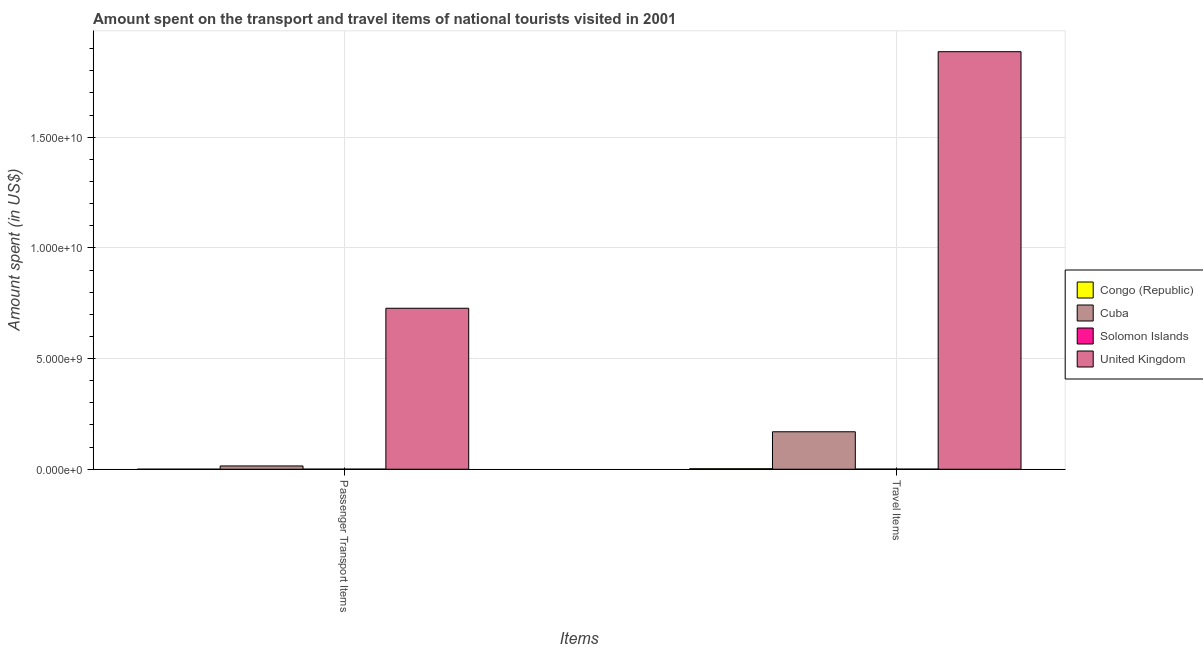How many different coloured bars are there?
Your answer should be very brief. 4. Are the number of bars per tick equal to the number of legend labels?
Make the answer very short. Yes. Are the number of bars on each tick of the X-axis equal?
Offer a very short reply. Yes. How many bars are there on the 2nd tick from the left?
Make the answer very short. 4. What is the label of the 2nd group of bars from the left?
Ensure brevity in your answer.  Travel Items. What is the amount spent on passenger transport items in Cuba?
Offer a terse response. 1.48e+08. Across all countries, what is the maximum amount spent in travel items?
Ensure brevity in your answer.  1.89e+1. Across all countries, what is the minimum amount spent on passenger transport items?
Your response must be concise. 6.00e+05. In which country was the amount spent on passenger transport items minimum?
Provide a short and direct response. Congo (Republic). What is the total amount spent in travel items in the graph?
Your answer should be compact. 2.06e+1. What is the difference between the amount spent in travel items in Cuba and that in Congo (Republic)?
Provide a short and direct response. 1.67e+09. What is the difference between the amount spent in travel items in Congo (Republic) and the amount spent on passenger transport items in Solomon Islands?
Make the answer very short. 1.84e+07. What is the average amount spent in travel items per country?
Your response must be concise. 5.15e+09. What is the difference between the amount spent in travel items and amount spent on passenger transport items in Congo (Republic)?
Keep it short and to the point. 2.14e+07. In how many countries, is the amount spent on passenger transport items greater than 13000000000 US$?
Offer a very short reply. 0. What is the ratio of the amount spent in travel items in Congo (Republic) to that in Solomon Islands?
Provide a short and direct response. 4.23. Is the amount spent in travel items in Solomon Islands less than that in Cuba?
Ensure brevity in your answer.  Yes. In how many countries, is the amount spent on passenger transport items greater than the average amount spent on passenger transport items taken over all countries?
Give a very brief answer. 1. What does the 3rd bar from the left in Passenger Transport Items represents?
Offer a terse response. Solomon Islands. What does the 4th bar from the right in Travel Items represents?
Offer a terse response. Congo (Republic). How many bars are there?
Offer a terse response. 8. How many countries are there in the graph?
Provide a short and direct response. 4. What is the difference between two consecutive major ticks on the Y-axis?
Offer a terse response. 5.00e+09. Are the values on the major ticks of Y-axis written in scientific E-notation?
Offer a very short reply. Yes. Where does the legend appear in the graph?
Offer a terse response. Center right. How many legend labels are there?
Offer a terse response. 4. How are the legend labels stacked?
Offer a very short reply. Vertical. What is the title of the graph?
Provide a succinct answer. Amount spent on the transport and travel items of national tourists visited in 2001. What is the label or title of the X-axis?
Keep it short and to the point. Items. What is the label or title of the Y-axis?
Provide a short and direct response. Amount spent (in US$). What is the Amount spent (in US$) of Congo (Republic) in Passenger Transport Items?
Provide a succinct answer. 6.00e+05. What is the Amount spent (in US$) in Cuba in Passenger Transport Items?
Provide a short and direct response. 1.48e+08. What is the Amount spent (in US$) of Solomon Islands in Passenger Transport Items?
Offer a very short reply. 3.60e+06. What is the Amount spent (in US$) of United Kingdom in Passenger Transport Items?
Offer a very short reply. 7.27e+09. What is the Amount spent (in US$) of Congo (Republic) in Travel Items?
Provide a succinct answer. 2.20e+07. What is the Amount spent (in US$) in Cuba in Travel Items?
Provide a succinct answer. 1.69e+09. What is the Amount spent (in US$) of Solomon Islands in Travel Items?
Give a very brief answer. 5.20e+06. What is the Amount spent (in US$) in United Kingdom in Travel Items?
Your response must be concise. 1.89e+1. Across all Items, what is the maximum Amount spent (in US$) in Congo (Republic)?
Ensure brevity in your answer.  2.20e+07. Across all Items, what is the maximum Amount spent (in US$) in Cuba?
Offer a terse response. 1.69e+09. Across all Items, what is the maximum Amount spent (in US$) of Solomon Islands?
Ensure brevity in your answer.  5.20e+06. Across all Items, what is the maximum Amount spent (in US$) of United Kingdom?
Offer a very short reply. 1.89e+1. Across all Items, what is the minimum Amount spent (in US$) of Cuba?
Keep it short and to the point. 1.48e+08. Across all Items, what is the minimum Amount spent (in US$) in Solomon Islands?
Your response must be concise. 3.60e+06. Across all Items, what is the minimum Amount spent (in US$) of United Kingdom?
Your answer should be compact. 7.27e+09. What is the total Amount spent (in US$) of Congo (Republic) in the graph?
Your answer should be compact. 2.26e+07. What is the total Amount spent (in US$) in Cuba in the graph?
Keep it short and to the point. 1.84e+09. What is the total Amount spent (in US$) in Solomon Islands in the graph?
Provide a short and direct response. 8.80e+06. What is the total Amount spent (in US$) in United Kingdom in the graph?
Make the answer very short. 2.61e+1. What is the difference between the Amount spent (in US$) in Congo (Republic) in Passenger Transport Items and that in Travel Items?
Offer a terse response. -2.14e+07. What is the difference between the Amount spent (in US$) of Cuba in Passenger Transport Items and that in Travel Items?
Your response must be concise. -1.54e+09. What is the difference between the Amount spent (in US$) of Solomon Islands in Passenger Transport Items and that in Travel Items?
Provide a succinct answer. -1.60e+06. What is the difference between the Amount spent (in US$) of United Kingdom in Passenger Transport Items and that in Travel Items?
Your answer should be compact. -1.16e+1. What is the difference between the Amount spent (in US$) of Congo (Republic) in Passenger Transport Items and the Amount spent (in US$) of Cuba in Travel Items?
Keep it short and to the point. -1.69e+09. What is the difference between the Amount spent (in US$) of Congo (Republic) in Passenger Transport Items and the Amount spent (in US$) of Solomon Islands in Travel Items?
Ensure brevity in your answer.  -4.60e+06. What is the difference between the Amount spent (in US$) in Congo (Republic) in Passenger Transport Items and the Amount spent (in US$) in United Kingdom in Travel Items?
Make the answer very short. -1.89e+1. What is the difference between the Amount spent (in US$) of Cuba in Passenger Transport Items and the Amount spent (in US$) of Solomon Islands in Travel Items?
Offer a very short reply. 1.43e+08. What is the difference between the Amount spent (in US$) of Cuba in Passenger Transport Items and the Amount spent (in US$) of United Kingdom in Travel Items?
Offer a very short reply. -1.87e+1. What is the difference between the Amount spent (in US$) in Solomon Islands in Passenger Transport Items and the Amount spent (in US$) in United Kingdom in Travel Items?
Your response must be concise. -1.89e+1. What is the average Amount spent (in US$) of Congo (Republic) per Items?
Offer a very short reply. 1.13e+07. What is the average Amount spent (in US$) in Cuba per Items?
Give a very brief answer. 9.20e+08. What is the average Amount spent (in US$) of Solomon Islands per Items?
Ensure brevity in your answer.  4.40e+06. What is the average Amount spent (in US$) in United Kingdom per Items?
Provide a short and direct response. 1.31e+1. What is the difference between the Amount spent (in US$) of Congo (Republic) and Amount spent (in US$) of Cuba in Passenger Transport Items?
Offer a very short reply. -1.47e+08. What is the difference between the Amount spent (in US$) of Congo (Republic) and Amount spent (in US$) of United Kingdom in Passenger Transport Items?
Your response must be concise. -7.27e+09. What is the difference between the Amount spent (in US$) in Cuba and Amount spent (in US$) in Solomon Islands in Passenger Transport Items?
Provide a short and direct response. 1.44e+08. What is the difference between the Amount spent (in US$) of Cuba and Amount spent (in US$) of United Kingdom in Passenger Transport Items?
Your response must be concise. -7.12e+09. What is the difference between the Amount spent (in US$) in Solomon Islands and Amount spent (in US$) in United Kingdom in Passenger Transport Items?
Your answer should be very brief. -7.27e+09. What is the difference between the Amount spent (in US$) in Congo (Republic) and Amount spent (in US$) in Cuba in Travel Items?
Your answer should be compact. -1.67e+09. What is the difference between the Amount spent (in US$) of Congo (Republic) and Amount spent (in US$) of Solomon Islands in Travel Items?
Keep it short and to the point. 1.68e+07. What is the difference between the Amount spent (in US$) of Congo (Republic) and Amount spent (in US$) of United Kingdom in Travel Items?
Give a very brief answer. -1.88e+1. What is the difference between the Amount spent (in US$) of Cuba and Amount spent (in US$) of Solomon Islands in Travel Items?
Your answer should be compact. 1.69e+09. What is the difference between the Amount spent (in US$) in Cuba and Amount spent (in US$) in United Kingdom in Travel Items?
Offer a terse response. -1.72e+1. What is the difference between the Amount spent (in US$) in Solomon Islands and Amount spent (in US$) in United Kingdom in Travel Items?
Make the answer very short. -1.89e+1. What is the ratio of the Amount spent (in US$) in Congo (Republic) in Passenger Transport Items to that in Travel Items?
Offer a terse response. 0.03. What is the ratio of the Amount spent (in US$) of Cuba in Passenger Transport Items to that in Travel Items?
Your answer should be compact. 0.09. What is the ratio of the Amount spent (in US$) in Solomon Islands in Passenger Transport Items to that in Travel Items?
Make the answer very short. 0.69. What is the ratio of the Amount spent (in US$) in United Kingdom in Passenger Transport Items to that in Travel Items?
Provide a short and direct response. 0.39. What is the difference between the highest and the second highest Amount spent (in US$) in Congo (Republic)?
Provide a succinct answer. 2.14e+07. What is the difference between the highest and the second highest Amount spent (in US$) of Cuba?
Offer a terse response. 1.54e+09. What is the difference between the highest and the second highest Amount spent (in US$) of Solomon Islands?
Keep it short and to the point. 1.60e+06. What is the difference between the highest and the second highest Amount spent (in US$) of United Kingdom?
Your response must be concise. 1.16e+1. What is the difference between the highest and the lowest Amount spent (in US$) of Congo (Republic)?
Your answer should be very brief. 2.14e+07. What is the difference between the highest and the lowest Amount spent (in US$) of Cuba?
Make the answer very short. 1.54e+09. What is the difference between the highest and the lowest Amount spent (in US$) of Solomon Islands?
Your response must be concise. 1.60e+06. What is the difference between the highest and the lowest Amount spent (in US$) of United Kingdom?
Provide a short and direct response. 1.16e+1. 